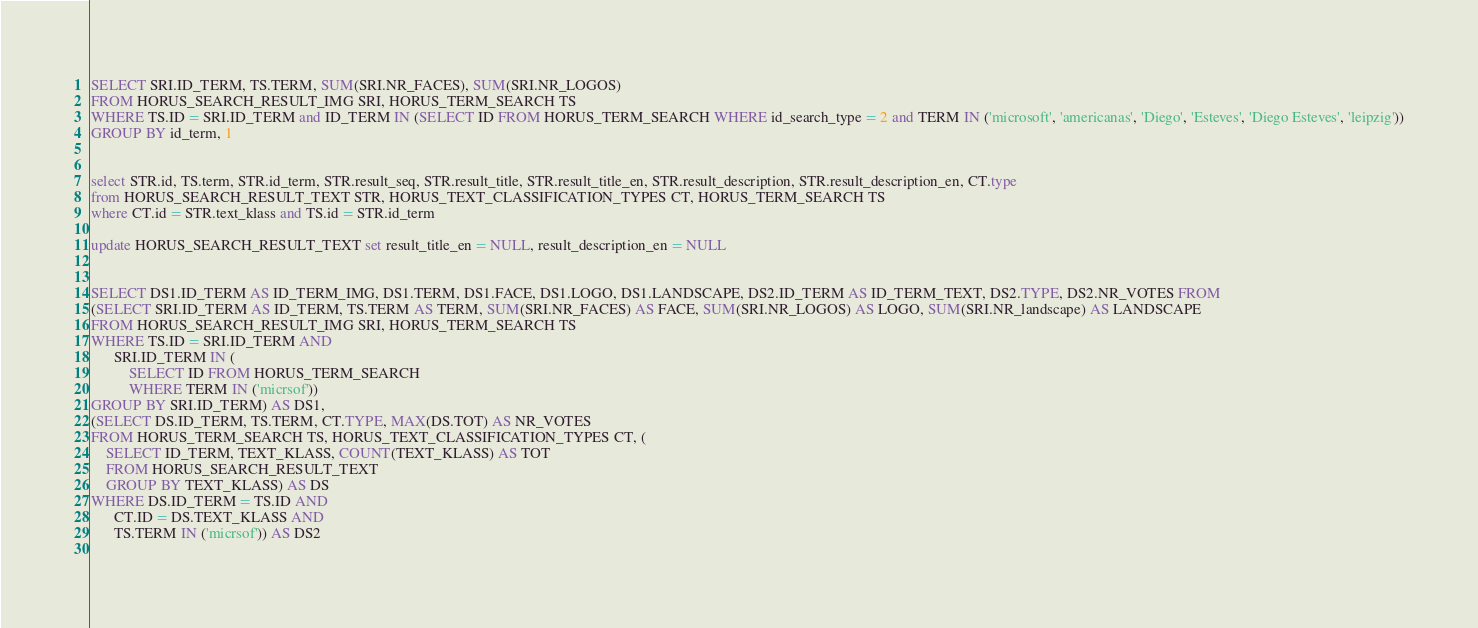<code> <loc_0><loc_0><loc_500><loc_500><_SQL_>SELECT SRI.ID_TERM, TS.TERM, SUM(SRI.NR_FACES), SUM(SRI.NR_LOGOS)
FROM HORUS_SEARCH_RESULT_IMG SRI, HORUS_TERM_SEARCH TS
WHERE TS.ID = SRI.ID_TERM and ID_TERM IN (SELECT ID FROM HORUS_TERM_SEARCH WHERE id_search_type = 2 and TERM IN ('microsoft', 'americanas', 'Diego', 'Esteves', 'Diego Esteves', 'leipzig'))
GROUP BY id_term, 1


select STR.id, TS.term, STR.id_term, STR.result_seq, STR.result_title, STR.result_title_en, STR.result_description, STR.result_description_en, CT.type
from HORUS_SEARCH_RESULT_TEXT STR, HORUS_TEXT_CLASSIFICATION_TYPES CT, HORUS_TERM_SEARCH TS
where CT.id = STR.text_klass and TS.id = STR.id_term

update HORUS_SEARCH_RESULT_TEXT set result_title_en = NULL, result_description_en = NULL 


SELECT DS1.ID_TERM AS ID_TERM_IMG, DS1.TERM, DS1.FACE, DS1.LOGO, DS1.LANDSCAPE, DS2.ID_TERM AS ID_TERM_TEXT, DS2.TYPE, DS2.NR_VOTES FROM
(SELECT SRI.ID_TERM AS ID_TERM, TS.TERM AS TERM, SUM(SRI.NR_FACES) AS FACE, SUM(SRI.NR_LOGOS) AS LOGO, SUM(SRI.NR_landscape) AS LANDSCAPE
FROM HORUS_SEARCH_RESULT_IMG SRI, HORUS_TERM_SEARCH TS
WHERE TS.ID = SRI.ID_TERM AND
      SRI.ID_TERM IN (
	      SELECT ID FROM HORUS_TERM_SEARCH  
		  WHERE TERM IN ('micrsof'))
GROUP BY SRI.ID_TERM) AS DS1,
(SELECT DS.ID_TERM, TS.TERM, CT.TYPE, MAX(DS.TOT) AS NR_VOTES 
FROM HORUS_TERM_SEARCH TS, HORUS_TEXT_CLASSIFICATION_TYPES CT, (
	SELECT ID_TERM, TEXT_KLASS, COUNT(TEXT_KLASS) AS TOT
	FROM HORUS_SEARCH_RESULT_TEXT
	GROUP BY TEXT_KLASS) AS DS
WHERE DS.ID_TERM = TS.ID AND
      CT.ID = DS.TEXT_KLASS AND
      TS.TERM IN ('micrsof')) AS DS2
	</code> 